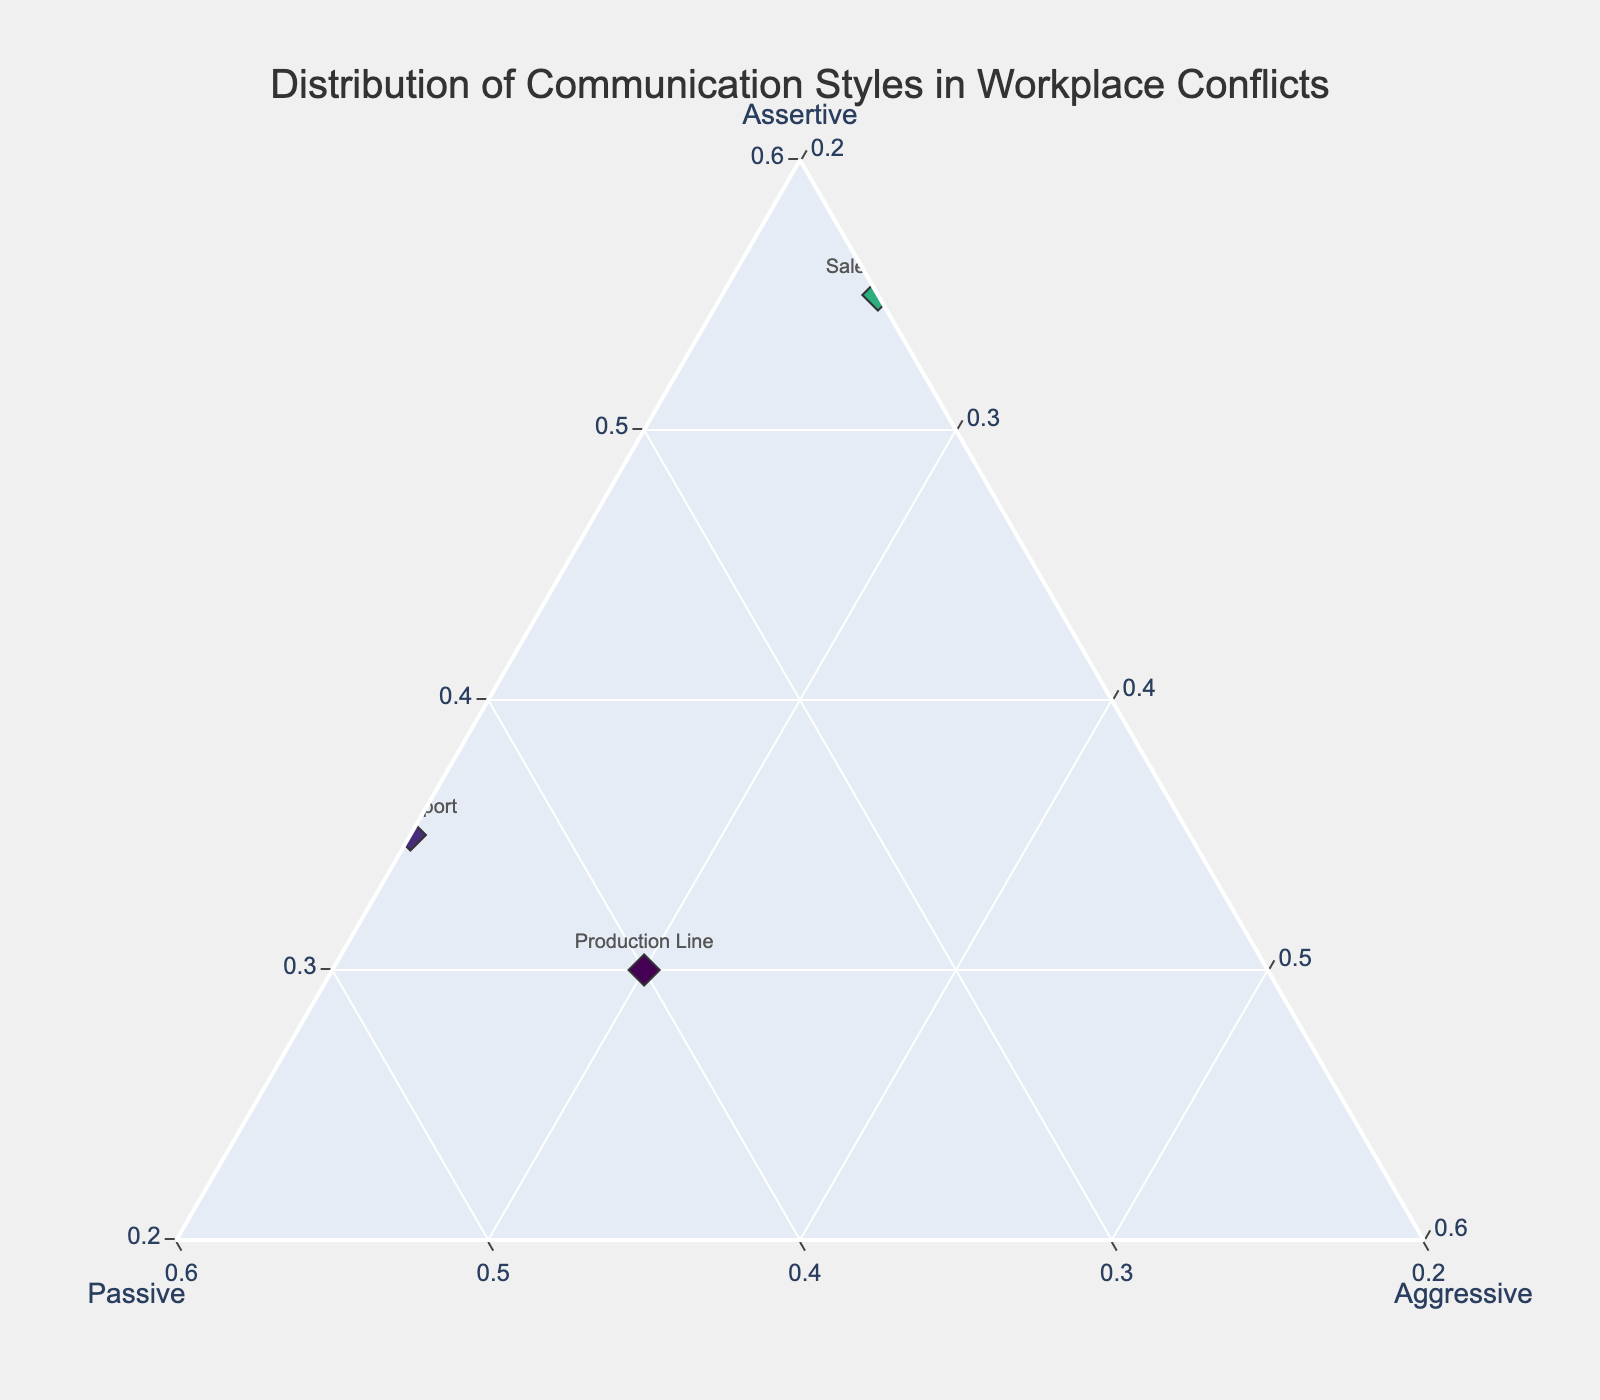What's the title of the figure? The title is given at the top of the plot, usually in a larger font and more prominent.
Answer: Distribution of Communication Styles in Workplace Conflicts How many data points are represented in the figure? The number of data points corresponds to the number of groups listed on the plot. Counting them gives 10 data points.
Answer: 10 Which group has the highest percentage of assertive communication? By looking at the axis labeled 'Assertive' and finding the group that is plotted furthest in its direction (having the highest assertive value), it is the Executive Board with 0.70.
Answer: Executive Board Which group has the highest percentage of passive communication? By looking at the axis labeled 'Passive' and finding the group that is plotted furthest in its direction, it is the Customer Service with 0.50.
Answer: Customer Service Which group has the highest percentage of aggressive communication? By looking at the axis labeled 'Aggressive' and finding the group that is plotted furthest in its direction, it is the Production Line with 0.30.
Answer: Production Line Compare the assertive communication style between the Marketing Team and the Sales Team. From the figure, we note the percentages: Marketing Team has 0.60 and Sales Team has 0.55. Thus, the Marketing Team has a slightly higher assertive percentage.
Answer: Marketing Team has higher assertive communication Which group has an equal percentage of passive and aggressive communication? By evaluating the positions relative to the 'Passive' and 'Aggressive' axes, only the IT Support group shows an equal percentage with 0.45 for both passive and aggressive communication.
Answer: IT Support What is the average assertive communication percentage across all groups? Summing up the assertive percentages for all groups (0.60 + 0.45 + 0.35 + 0.55 + 0.70 + 0.40 + 0.50 + 0.55 + 0.30 + 0.65) gives 5.05, and dividing by the number of groups (10) results in 0.505.
Answer: 0.505 Which groups have more than 50% assertive communication? By inspecting the figure, groups with more than 0.50 on the assertive axis are: Marketing Team, Sales Team, Executive Board, Finance Team, and Legal Department.
Answer: Marketing Team, Sales Team, Executive Board, Finance Team, and Legal Department Among the Finance Team and the R&D Department, which group is less aggressive? The Finance Team's aggressive percentage is 0.15 while the R&D Department's aggressive percentage is also 0.15. Thus, they are equally aggressive.
Answer: They are equal 